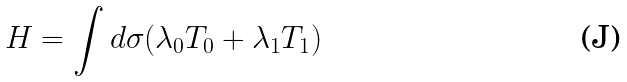Convert formula to latex. <formula><loc_0><loc_0><loc_500><loc_500>H = \int d \sigma ( \lambda _ { 0 } T _ { 0 } + \lambda _ { 1 } T _ { 1 } )</formula> 